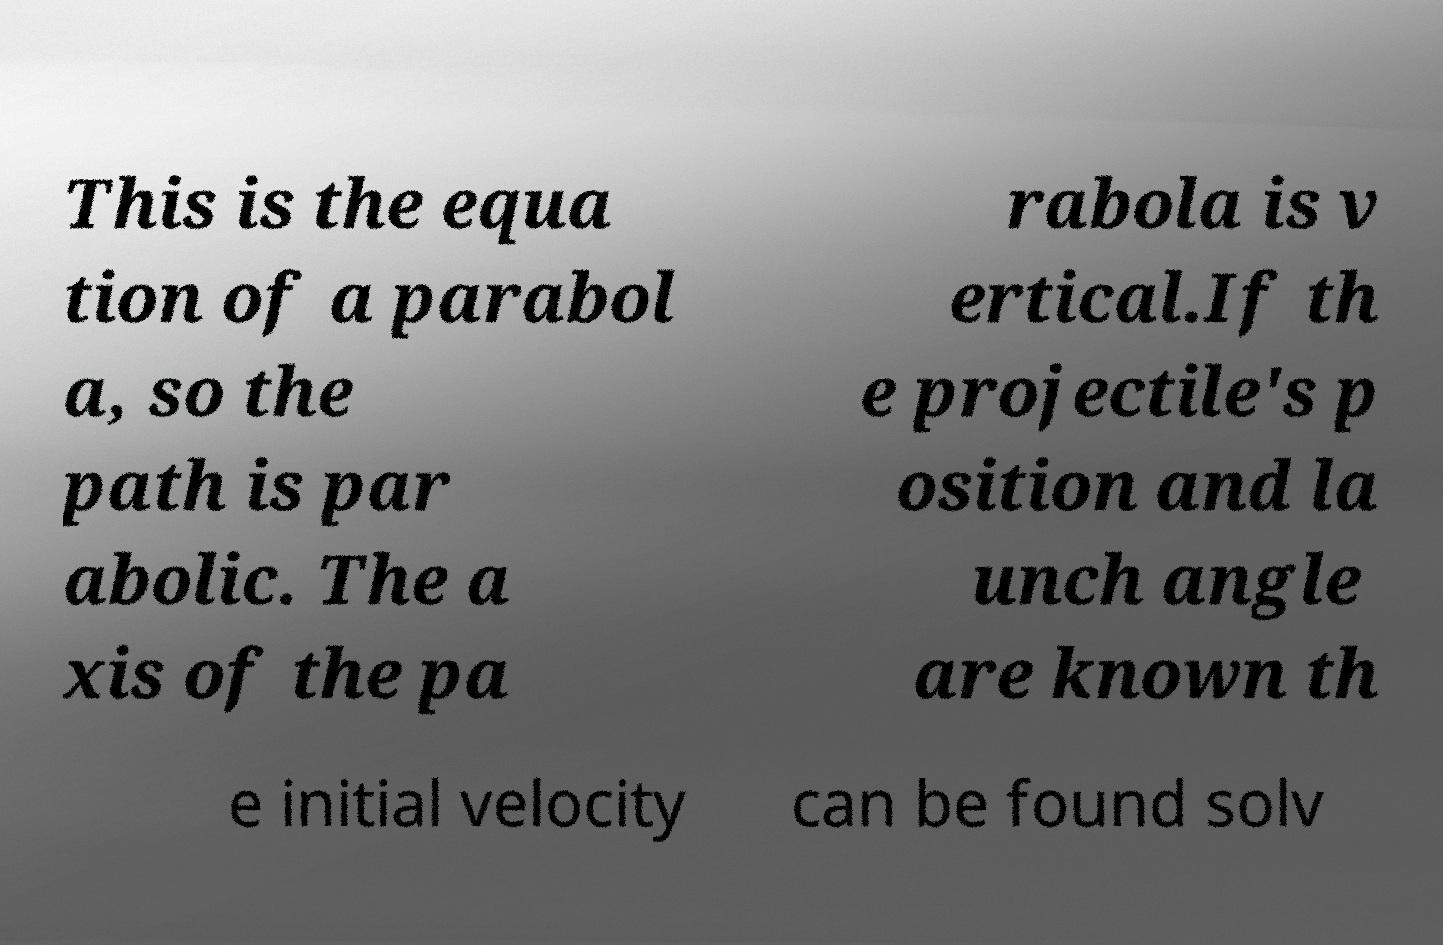Can you read and provide the text displayed in the image?This photo seems to have some interesting text. Can you extract and type it out for me? This is the equa tion of a parabol a, so the path is par abolic. The a xis of the pa rabola is v ertical.If th e projectile's p osition and la unch angle are known th e initial velocity can be found solv 